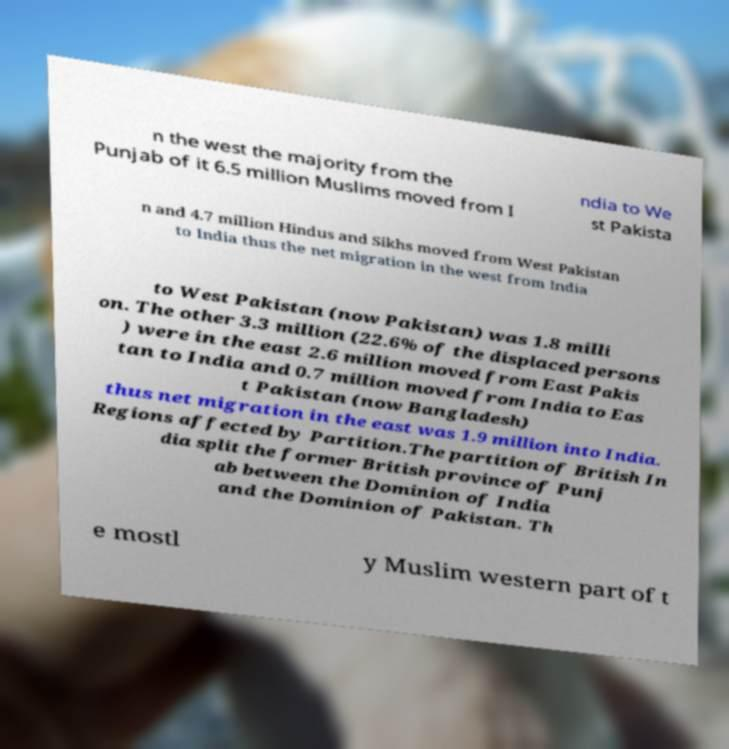What messages or text are displayed in this image? I need them in a readable, typed format. n the west the majority from the Punjab of it 6.5 million Muslims moved from I ndia to We st Pakista n and 4.7 million Hindus and Sikhs moved from West Pakistan to India thus the net migration in the west from India to West Pakistan (now Pakistan) was 1.8 milli on. The other 3.3 million (22.6% of the displaced persons ) were in the east 2.6 million moved from East Pakis tan to India and 0.7 million moved from India to Eas t Pakistan (now Bangladesh) thus net migration in the east was 1.9 million into India. Regions affected by Partition.The partition of British In dia split the former British province of Punj ab between the Dominion of India and the Dominion of Pakistan. Th e mostl y Muslim western part of t 